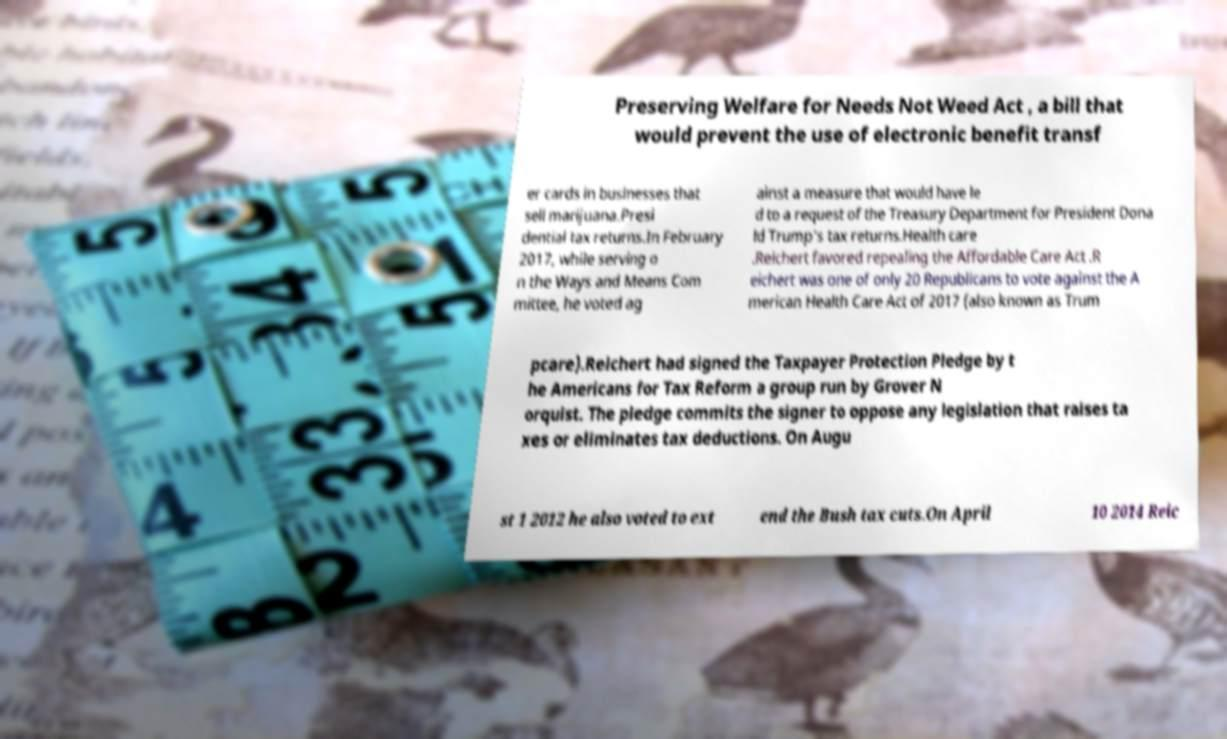Can you read and provide the text displayed in the image?This photo seems to have some interesting text. Can you extract and type it out for me? Preserving Welfare for Needs Not Weed Act , a bill that would prevent the use of electronic benefit transf er cards in businesses that sell marijuana.Presi dential tax returns.In February 2017, while serving o n the Ways and Means Com mittee, he voted ag ainst a measure that would have le d to a request of the Treasury Department for President Dona ld Trump's tax returns.Health care .Reichert favored repealing the Affordable Care Act .R eichert was one of only 20 Republicans to vote against the A merican Health Care Act of 2017 (also known as Trum pcare).Reichert had signed the Taxpayer Protection Pledge by t he Americans for Tax Reform a group run by Grover N orquist. The pledge commits the signer to oppose any legislation that raises ta xes or eliminates tax deductions. On Augu st 1 2012 he also voted to ext end the Bush tax cuts.On April 10 2014 Reic 